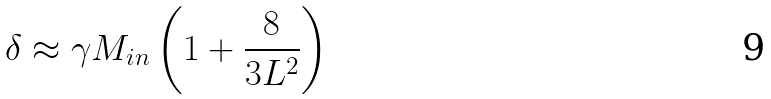<formula> <loc_0><loc_0><loc_500><loc_500>\delta \approx \gamma M _ { i n } \left ( 1 + \frac { 8 } { 3 L ^ { 2 } } \right )</formula> 